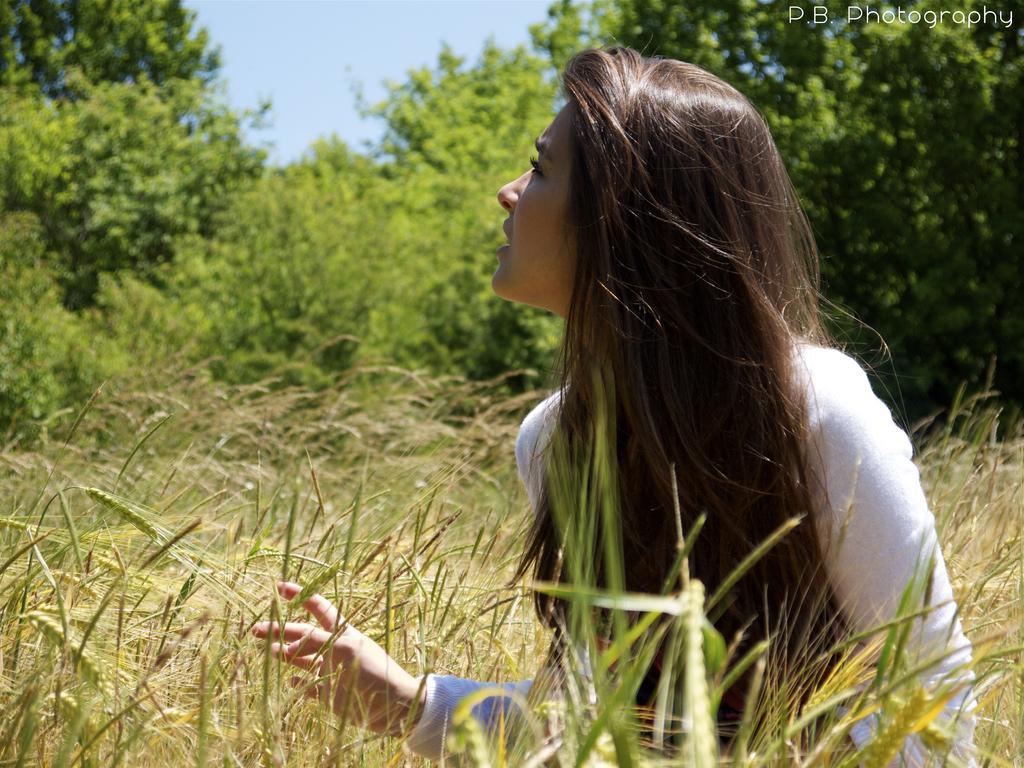Describe this image in one or two sentences. In this image we can see a lady. At the bottom there is a field. In the background there are trees and sky. 